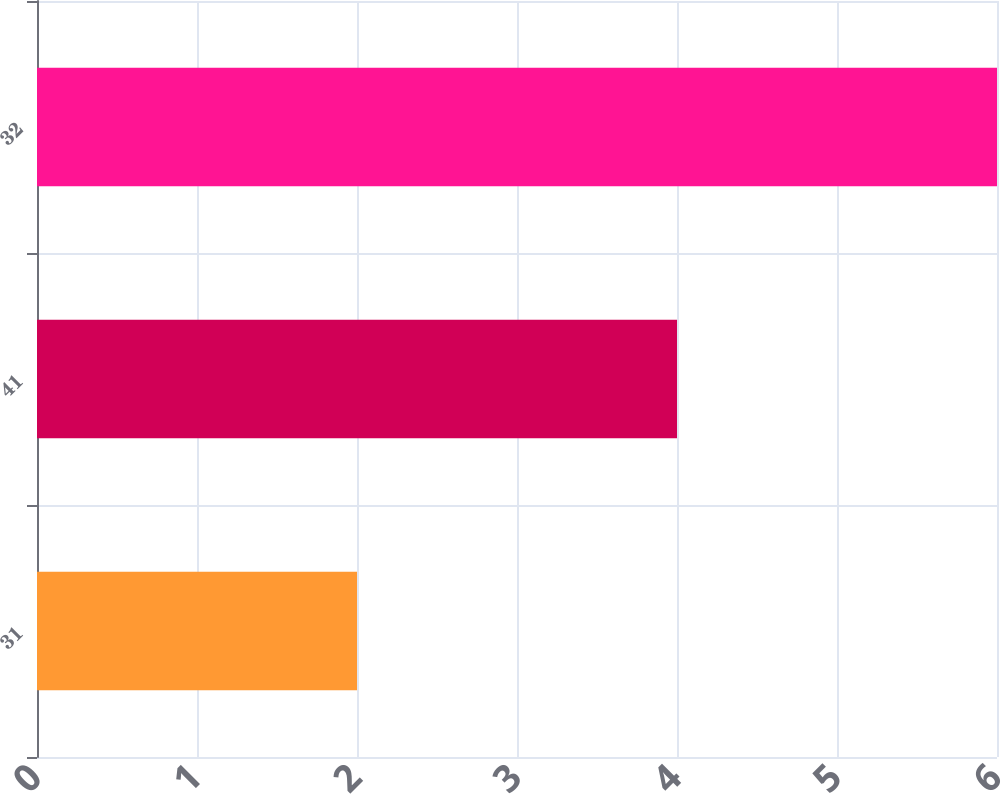<chart> <loc_0><loc_0><loc_500><loc_500><bar_chart><fcel>31<fcel>41<fcel>32<nl><fcel>2<fcel>4<fcel>6<nl></chart> 